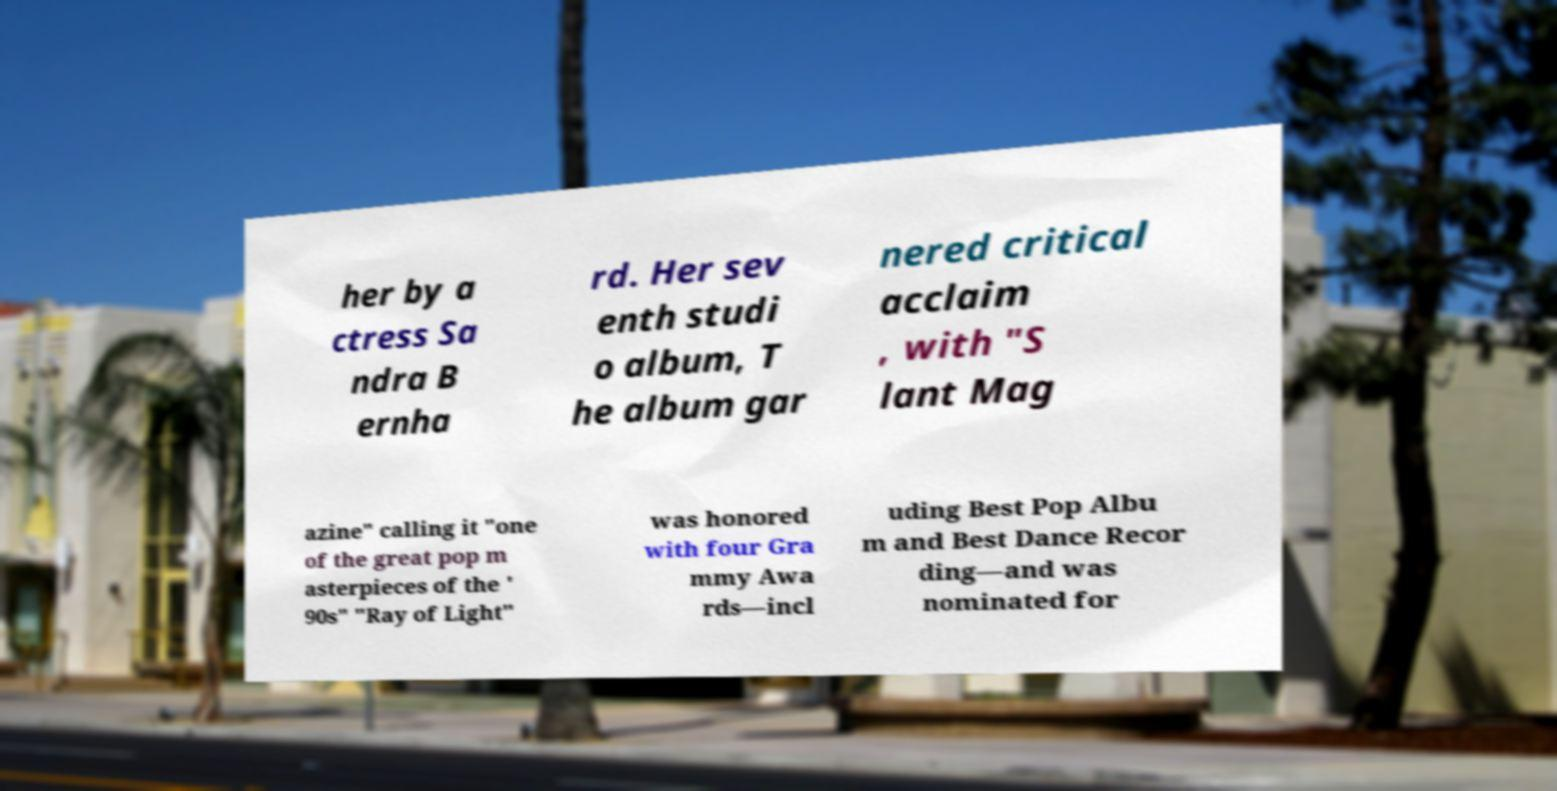Can you read and provide the text displayed in the image?This photo seems to have some interesting text. Can you extract and type it out for me? her by a ctress Sa ndra B ernha rd. Her sev enth studi o album, T he album gar nered critical acclaim , with "S lant Mag azine" calling it "one of the great pop m asterpieces of the ' 90s" "Ray of Light" was honored with four Gra mmy Awa rds—incl uding Best Pop Albu m and Best Dance Recor ding—and was nominated for 